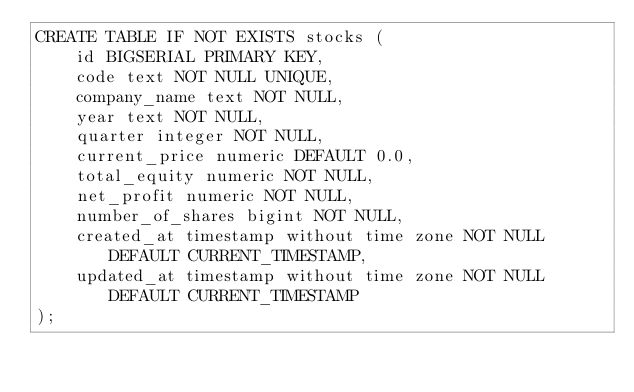Convert code to text. <code><loc_0><loc_0><loc_500><loc_500><_SQL_>CREATE TABLE IF NOT EXISTS stocks (
    id BIGSERIAL PRIMARY KEY,
    code text NOT NULL UNIQUE,
    company_name text NOT NULL,
    year text NOT NULL,
    quarter integer NOT NULL,
    current_price numeric DEFAULT 0.0,
    total_equity numeric NOT NULL,
    net_profit numeric NOT NULL,
    number_of_shares bigint NOT NULL,
    created_at timestamp without time zone NOT NULL DEFAULT CURRENT_TIMESTAMP,
    updated_at timestamp without time zone NOT NULL DEFAULT CURRENT_TIMESTAMP
);
</code> 